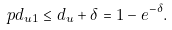<formula> <loc_0><loc_0><loc_500><loc_500>\ p { d _ { u 1 } \leq d _ { u } + \delta } = 1 - e ^ { - \delta } .</formula> 